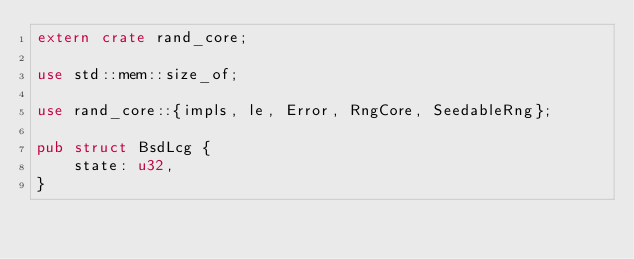<code> <loc_0><loc_0><loc_500><loc_500><_Rust_>extern crate rand_core;

use std::mem::size_of;

use rand_core::{impls, le, Error, RngCore, SeedableRng};

pub struct BsdLcg {
    state: u32,
}
</code> 